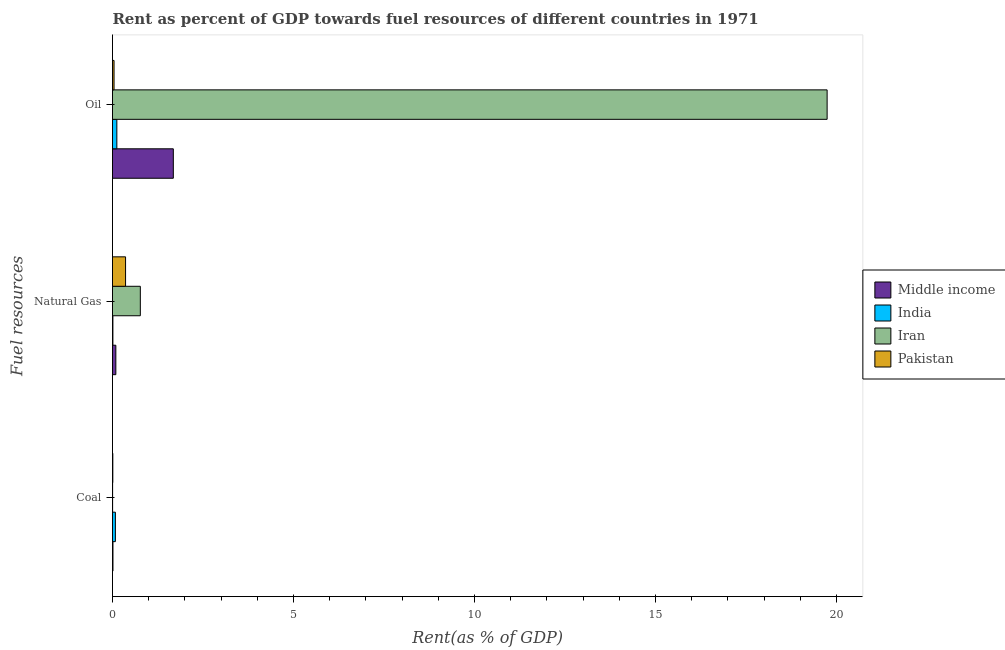How many different coloured bars are there?
Your answer should be compact. 4. How many groups of bars are there?
Your answer should be compact. 3. Are the number of bars on each tick of the Y-axis equal?
Provide a short and direct response. Yes. How many bars are there on the 3rd tick from the bottom?
Provide a succinct answer. 4. What is the label of the 2nd group of bars from the top?
Your answer should be compact. Natural Gas. What is the rent towards natural gas in Iran?
Ensure brevity in your answer.  0.77. Across all countries, what is the maximum rent towards oil?
Your response must be concise. 19.74. Across all countries, what is the minimum rent towards coal?
Ensure brevity in your answer.  0. In which country was the rent towards oil maximum?
Offer a very short reply. Iran. In which country was the rent towards natural gas minimum?
Your response must be concise. India. What is the total rent towards coal in the graph?
Provide a succinct answer. 0.1. What is the difference between the rent towards natural gas in Pakistan and that in Middle income?
Your answer should be compact. 0.27. What is the difference between the rent towards oil in Pakistan and the rent towards coal in Iran?
Offer a very short reply. 0.04. What is the average rent towards coal per country?
Ensure brevity in your answer.  0.03. What is the difference between the rent towards coal and rent towards natural gas in India?
Your response must be concise. 0.07. What is the ratio of the rent towards oil in Iran to that in India?
Offer a very short reply. 164.83. Is the rent towards oil in Pakistan less than that in India?
Keep it short and to the point. Yes. Is the difference between the rent towards natural gas in Middle income and India greater than the difference between the rent towards oil in Middle income and India?
Your answer should be compact. No. What is the difference between the highest and the second highest rent towards natural gas?
Keep it short and to the point. 0.41. What is the difference between the highest and the lowest rent towards coal?
Give a very brief answer. 0.08. In how many countries, is the rent towards coal greater than the average rent towards coal taken over all countries?
Your answer should be very brief. 1. Is it the case that in every country, the sum of the rent towards coal and rent towards natural gas is greater than the rent towards oil?
Provide a short and direct response. No. What is the difference between two consecutive major ticks on the X-axis?
Your response must be concise. 5. How many legend labels are there?
Ensure brevity in your answer.  4. What is the title of the graph?
Provide a short and direct response. Rent as percent of GDP towards fuel resources of different countries in 1971. What is the label or title of the X-axis?
Make the answer very short. Rent(as % of GDP). What is the label or title of the Y-axis?
Offer a very short reply. Fuel resources. What is the Rent(as % of GDP) of Middle income in Coal?
Ensure brevity in your answer.  0.01. What is the Rent(as % of GDP) of India in Coal?
Give a very brief answer. 0.08. What is the Rent(as % of GDP) of Iran in Coal?
Keep it short and to the point. 0. What is the Rent(as % of GDP) in Pakistan in Coal?
Your response must be concise. 0.01. What is the Rent(as % of GDP) of Middle income in Natural Gas?
Offer a terse response. 0.09. What is the Rent(as % of GDP) of India in Natural Gas?
Offer a very short reply. 0.01. What is the Rent(as % of GDP) in Iran in Natural Gas?
Your answer should be very brief. 0.77. What is the Rent(as % of GDP) in Pakistan in Natural Gas?
Ensure brevity in your answer.  0.36. What is the Rent(as % of GDP) in Middle income in Oil?
Your answer should be compact. 1.68. What is the Rent(as % of GDP) in India in Oil?
Provide a short and direct response. 0.12. What is the Rent(as % of GDP) in Iran in Oil?
Ensure brevity in your answer.  19.74. What is the Rent(as % of GDP) of Pakistan in Oil?
Ensure brevity in your answer.  0.04. Across all Fuel resources, what is the maximum Rent(as % of GDP) in Middle income?
Your response must be concise. 1.68. Across all Fuel resources, what is the maximum Rent(as % of GDP) of India?
Offer a terse response. 0.12. Across all Fuel resources, what is the maximum Rent(as % of GDP) of Iran?
Your answer should be very brief. 19.74. Across all Fuel resources, what is the maximum Rent(as % of GDP) in Pakistan?
Give a very brief answer. 0.36. Across all Fuel resources, what is the minimum Rent(as % of GDP) of Middle income?
Your response must be concise. 0.01. Across all Fuel resources, what is the minimum Rent(as % of GDP) of India?
Your answer should be very brief. 0.01. Across all Fuel resources, what is the minimum Rent(as % of GDP) in Iran?
Offer a very short reply. 0. Across all Fuel resources, what is the minimum Rent(as % of GDP) in Pakistan?
Offer a terse response. 0.01. What is the total Rent(as % of GDP) in Middle income in the graph?
Offer a very short reply. 1.79. What is the total Rent(as % of GDP) of India in the graph?
Provide a succinct answer. 0.21. What is the total Rent(as % of GDP) in Iran in the graph?
Keep it short and to the point. 20.52. What is the total Rent(as % of GDP) in Pakistan in the graph?
Provide a short and direct response. 0.41. What is the difference between the Rent(as % of GDP) of Middle income in Coal and that in Natural Gas?
Your answer should be very brief. -0.08. What is the difference between the Rent(as % of GDP) of India in Coal and that in Natural Gas?
Offer a terse response. 0.07. What is the difference between the Rent(as % of GDP) of Iran in Coal and that in Natural Gas?
Your answer should be very brief. -0.77. What is the difference between the Rent(as % of GDP) in Pakistan in Coal and that in Natural Gas?
Ensure brevity in your answer.  -0.35. What is the difference between the Rent(as % of GDP) of Middle income in Coal and that in Oil?
Give a very brief answer. -1.67. What is the difference between the Rent(as % of GDP) in India in Coal and that in Oil?
Keep it short and to the point. -0.04. What is the difference between the Rent(as % of GDP) in Iran in Coal and that in Oil?
Make the answer very short. -19.74. What is the difference between the Rent(as % of GDP) in Pakistan in Coal and that in Oil?
Offer a terse response. -0.03. What is the difference between the Rent(as % of GDP) in Middle income in Natural Gas and that in Oil?
Give a very brief answer. -1.59. What is the difference between the Rent(as % of GDP) in India in Natural Gas and that in Oil?
Keep it short and to the point. -0.11. What is the difference between the Rent(as % of GDP) in Iran in Natural Gas and that in Oil?
Provide a short and direct response. -18.98. What is the difference between the Rent(as % of GDP) in Pakistan in Natural Gas and that in Oil?
Give a very brief answer. 0.32. What is the difference between the Rent(as % of GDP) of Middle income in Coal and the Rent(as % of GDP) of India in Natural Gas?
Keep it short and to the point. 0. What is the difference between the Rent(as % of GDP) of Middle income in Coal and the Rent(as % of GDP) of Iran in Natural Gas?
Offer a terse response. -0.76. What is the difference between the Rent(as % of GDP) of Middle income in Coal and the Rent(as % of GDP) of Pakistan in Natural Gas?
Keep it short and to the point. -0.35. What is the difference between the Rent(as % of GDP) of India in Coal and the Rent(as % of GDP) of Iran in Natural Gas?
Your response must be concise. -0.69. What is the difference between the Rent(as % of GDP) in India in Coal and the Rent(as % of GDP) in Pakistan in Natural Gas?
Offer a terse response. -0.28. What is the difference between the Rent(as % of GDP) in Iran in Coal and the Rent(as % of GDP) in Pakistan in Natural Gas?
Your answer should be compact. -0.36. What is the difference between the Rent(as % of GDP) of Middle income in Coal and the Rent(as % of GDP) of India in Oil?
Offer a terse response. -0.11. What is the difference between the Rent(as % of GDP) of Middle income in Coal and the Rent(as % of GDP) of Iran in Oil?
Provide a succinct answer. -19.73. What is the difference between the Rent(as % of GDP) of Middle income in Coal and the Rent(as % of GDP) of Pakistan in Oil?
Provide a short and direct response. -0.03. What is the difference between the Rent(as % of GDP) of India in Coal and the Rent(as % of GDP) of Iran in Oil?
Your answer should be compact. -19.66. What is the difference between the Rent(as % of GDP) of India in Coal and the Rent(as % of GDP) of Pakistan in Oil?
Offer a very short reply. 0.04. What is the difference between the Rent(as % of GDP) in Iran in Coal and the Rent(as % of GDP) in Pakistan in Oil?
Your answer should be compact. -0.04. What is the difference between the Rent(as % of GDP) of Middle income in Natural Gas and the Rent(as % of GDP) of India in Oil?
Offer a terse response. -0.03. What is the difference between the Rent(as % of GDP) of Middle income in Natural Gas and the Rent(as % of GDP) of Iran in Oil?
Offer a very short reply. -19.65. What is the difference between the Rent(as % of GDP) of Middle income in Natural Gas and the Rent(as % of GDP) of Pakistan in Oil?
Offer a terse response. 0.05. What is the difference between the Rent(as % of GDP) of India in Natural Gas and the Rent(as % of GDP) of Iran in Oil?
Offer a very short reply. -19.73. What is the difference between the Rent(as % of GDP) in India in Natural Gas and the Rent(as % of GDP) in Pakistan in Oil?
Offer a terse response. -0.03. What is the difference between the Rent(as % of GDP) in Iran in Natural Gas and the Rent(as % of GDP) in Pakistan in Oil?
Offer a very short reply. 0.73. What is the average Rent(as % of GDP) in Middle income per Fuel resources?
Your answer should be very brief. 0.6. What is the average Rent(as % of GDP) of India per Fuel resources?
Your response must be concise. 0.07. What is the average Rent(as % of GDP) of Iran per Fuel resources?
Keep it short and to the point. 6.84. What is the average Rent(as % of GDP) of Pakistan per Fuel resources?
Offer a very short reply. 0.14. What is the difference between the Rent(as % of GDP) of Middle income and Rent(as % of GDP) of India in Coal?
Give a very brief answer. -0.07. What is the difference between the Rent(as % of GDP) of Middle income and Rent(as % of GDP) of Pakistan in Coal?
Make the answer very short. 0. What is the difference between the Rent(as % of GDP) in India and Rent(as % of GDP) in Iran in Coal?
Make the answer very short. 0.08. What is the difference between the Rent(as % of GDP) of India and Rent(as % of GDP) of Pakistan in Coal?
Make the answer very short. 0.07. What is the difference between the Rent(as % of GDP) of Iran and Rent(as % of GDP) of Pakistan in Coal?
Make the answer very short. -0.01. What is the difference between the Rent(as % of GDP) of Middle income and Rent(as % of GDP) of India in Natural Gas?
Keep it short and to the point. 0.08. What is the difference between the Rent(as % of GDP) in Middle income and Rent(as % of GDP) in Iran in Natural Gas?
Offer a terse response. -0.68. What is the difference between the Rent(as % of GDP) in Middle income and Rent(as % of GDP) in Pakistan in Natural Gas?
Keep it short and to the point. -0.27. What is the difference between the Rent(as % of GDP) in India and Rent(as % of GDP) in Iran in Natural Gas?
Offer a very short reply. -0.76. What is the difference between the Rent(as % of GDP) in India and Rent(as % of GDP) in Pakistan in Natural Gas?
Your answer should be compact. -0.35. What is the difference between the Rent(as % of GDP) of Iran and Rent(as % of GDP) of Pakistan in Natural Gas?
Offer a very short reply. 0.41. What is the difference between the Rent(as % of GDP) in Middle income and Rent(as % of GDP) in India in Oil?
Give a very brief answer. 1.56. What is the difference between the Rent(as % of GDP) of Middle income and Rent(as % of GDP) of Iran in Oil?
Make the answer very short. -18.06. What is the difference between the Rent(as % of GDP) in Middle income and Rent(as % of GDP) in Pakistan in Oil?
Ensure brevity in your answer.  1.64. What is the difference between the Rent(as % of GDP) of India and Rent(as % of GDP) of Iran in Oil?
Provide a short and direct response. -19.62. What is the difference between the Rent(as % of GDP) in India and Rent(as % of GDP) in Pakistan in Oil?
Your answer should be compact. 0.08. What is the difference between the Rent(as % of GDP) of Iran and Rent(as % of GDP) of Pakistan in Oil?
Provide a short and direct response. 19.7. What is the ratio of the Rent(as % of GDP) in Middle income in Coal to that in Natural Gas?
Ensure brevity in your answer.  0.14. What is the ratio of the Rent(as % of GDP) in India in Coal to that in Natural Gas?
Your response must be concise. 7.14. What is the ratio of the Rent(as % of GDP) in Iran in Coal to that in Natural Gas?
Keep it short and to the point. 0. What is the ratio of the Rent(as % of GDP) in Pakistan in Coal to that in Natural Gas?
Provide a short and direct response. 0.02. What is the ratio of the Rent(as % of GDP) in Middle income in Coal to that in Oil?
Provide a short and direct response. 0.01. What is the ratio of the Rent(as % of GDP) of India in Coal to that in Oil?
Ensure brevity in your answer.  0.67. What is the ratio of the Rent(as % of GDP) in Iran in Coal to that in Oil?
Your answer should be very brief. 0. What is the ratio of the Rent(as % of GDP) in Pakistan in Coal to that in Oil?
Give a very brief answer. 0.21. What is the ratio of the Rent(as % of GDP) of Middle income in Natural Gas to that in Oil?
Provide a short and direct response. 0.06. What is the ratio of the Rent(as % of GDP) of India in Natural Gas to that in Oil?
Your answer should be very brief. 0.09. What is the ratio of the Rent(as % of GDP) in Iran in Natural Gas to that in Oil?
Provide a succinct answer. 0.04. What is the ratio of the Rent(as % of GDP) in Pakistan in Natural Gas to that in Oil?
Provide a short and direct response. 8.47. What is the difference between the highest and the second highest Rent(as % of GDP) of Middle income?
Provide a succinct answer. 1.59. What is the difference between the highest and the second highest Rent(as % of GDP) of India?
Ensure brevity in your answer.  0.04. What is the difference between the highest and the second highest Rent(as % of GDP) in Iran?
Keep it short and to the point. 18.98. What is the difference between the highest and the second highest Rent(as % of GDP) in Pakistan?
Keep it short and to the point. 0.32. What is the difference between the highest and the lowest Rent(as % of GDP) of Middle income?
Provide a short and direct response. 1.67. What is the difference between the highest and the lowest Rent(as % of GDP) of India?
Offer a very short reply. 0.11. What is the difference between the highest and the lowest Rent(as % of GDP) in Iran?
Ensure brevity in your answer.  19.74. What is the difference between the highest and the lowest Rent(as % of GDP) of Pakistan?
Your response must be concise. 0.35. 